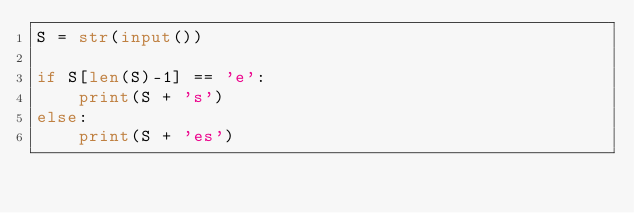<code> <loc_0><loc_0><loc_500><loc_500><_Python_>S = str(input())

if S[len(S)-1] == 'e':
    print(S + 's')
else:
    print(S + 'es')</code> 